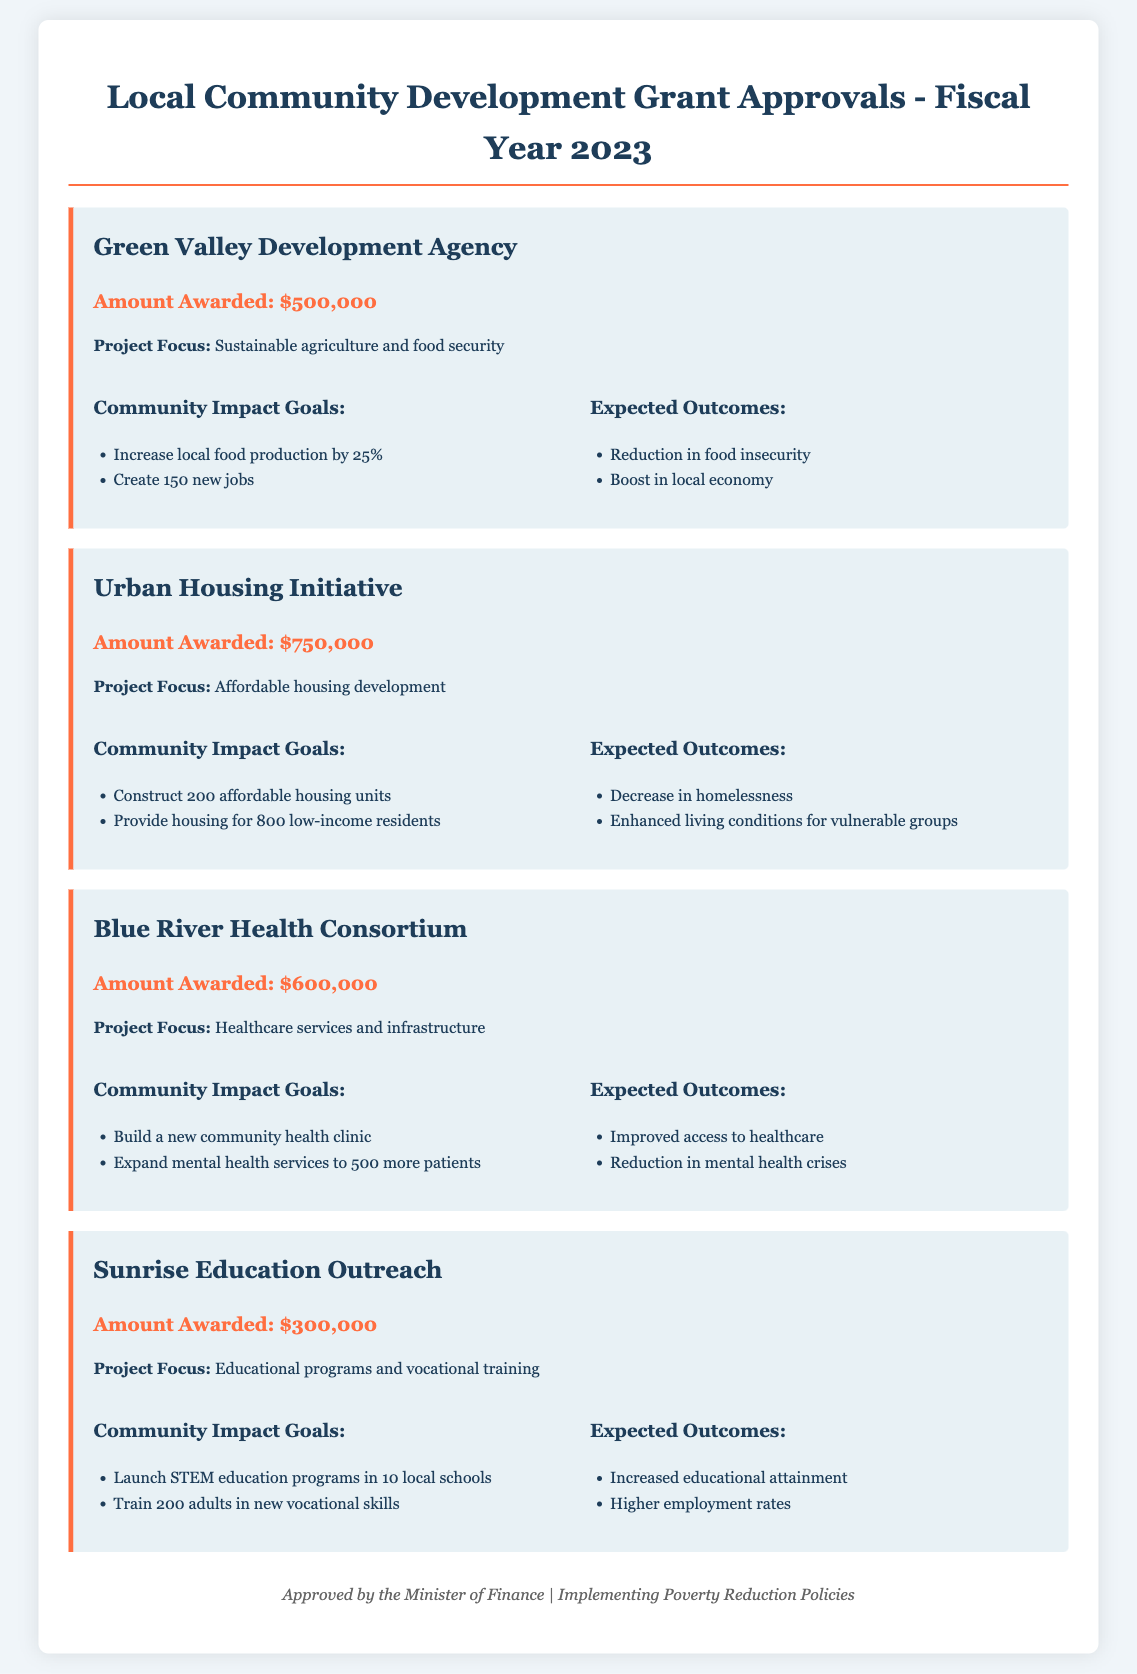What is the total amount awarded for grants? The total amount awarded is the sum of all grants, which is $500,000 + $750,000 + $600,000 + $300,000 = $2,150,000.
Answer: $2,150,000 How many affordable housing units will be constructed? The document states that the Urban Housing Initiative aims to construct 200 affordable housing units.
Answer: 200 What is the project focus of the Blue River Health Consortium? The project focus of the Blue River Health Consortium is healthcare services and infrastructure.
Answer: Healthcare services and infrastructure How many jobs will the Green Valley Development Agency create? The community impact goal states that the Green Valley Development Agency aims to create 150 new jobs.
Answer: 150 What is one expected outcome of the Sunrise Education Outreach project? One expected outcome of the Sunrise Education Outreach project is increased educational attainment.
Answer: Increased educational attainment What is the amount awarded to the Urban Housing Initiative? The document specifies that the amount awarded to the Urban Housing Initiative is $750,000.
Answer: $750,000 Which project focuses on sustainable agriculture? The project that focuses on sustainable agriculture is the Green Valley Development Agency.
Answer: Green Valley Development Agency What is the impact goal for the Blue River Health Consortium? The document states that one impact goal is to expand mental health services to 500 more patients.
Answer: Expand mental health services to 500 more patients How much funding was allocated for educational programs? The Sunrise Education Outreach was awarded $300,000 for educational programs and vocational training.
Answer: $300,000 